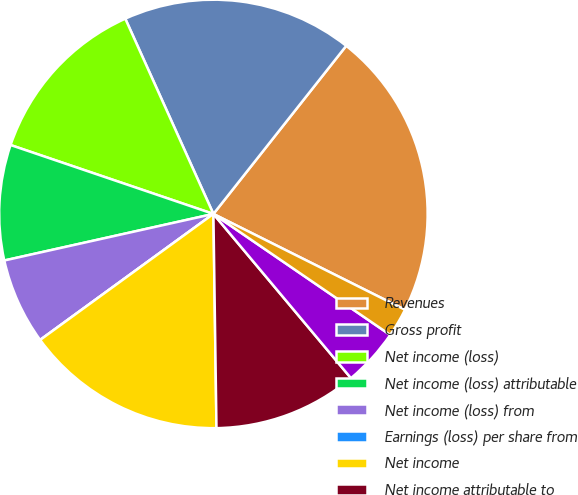Convert chart. <chart><loc_0><loc_0><loc_500><loc_500><pie_chart><fcel>Revenues<fcel>Gross profit<fcel>Net income (loss)<fcel>Net income (loss) attributable<fcel>Net income (loss) from<fcel>Earnings (loss) per share from<fcel>Net income<fcel>Net income attributable to<fcel>Net income from continuing<fcel>Earnings per share from<nl><fcel>21.74%<fcel>17.39%<fcel>13.04%<fcel>8.7%<fcel>6.52%<fcel>0.0%<fcel>15.22%<fcel>10.87%<fcel>4.35%<fcel>2.17%<nl></chart> 